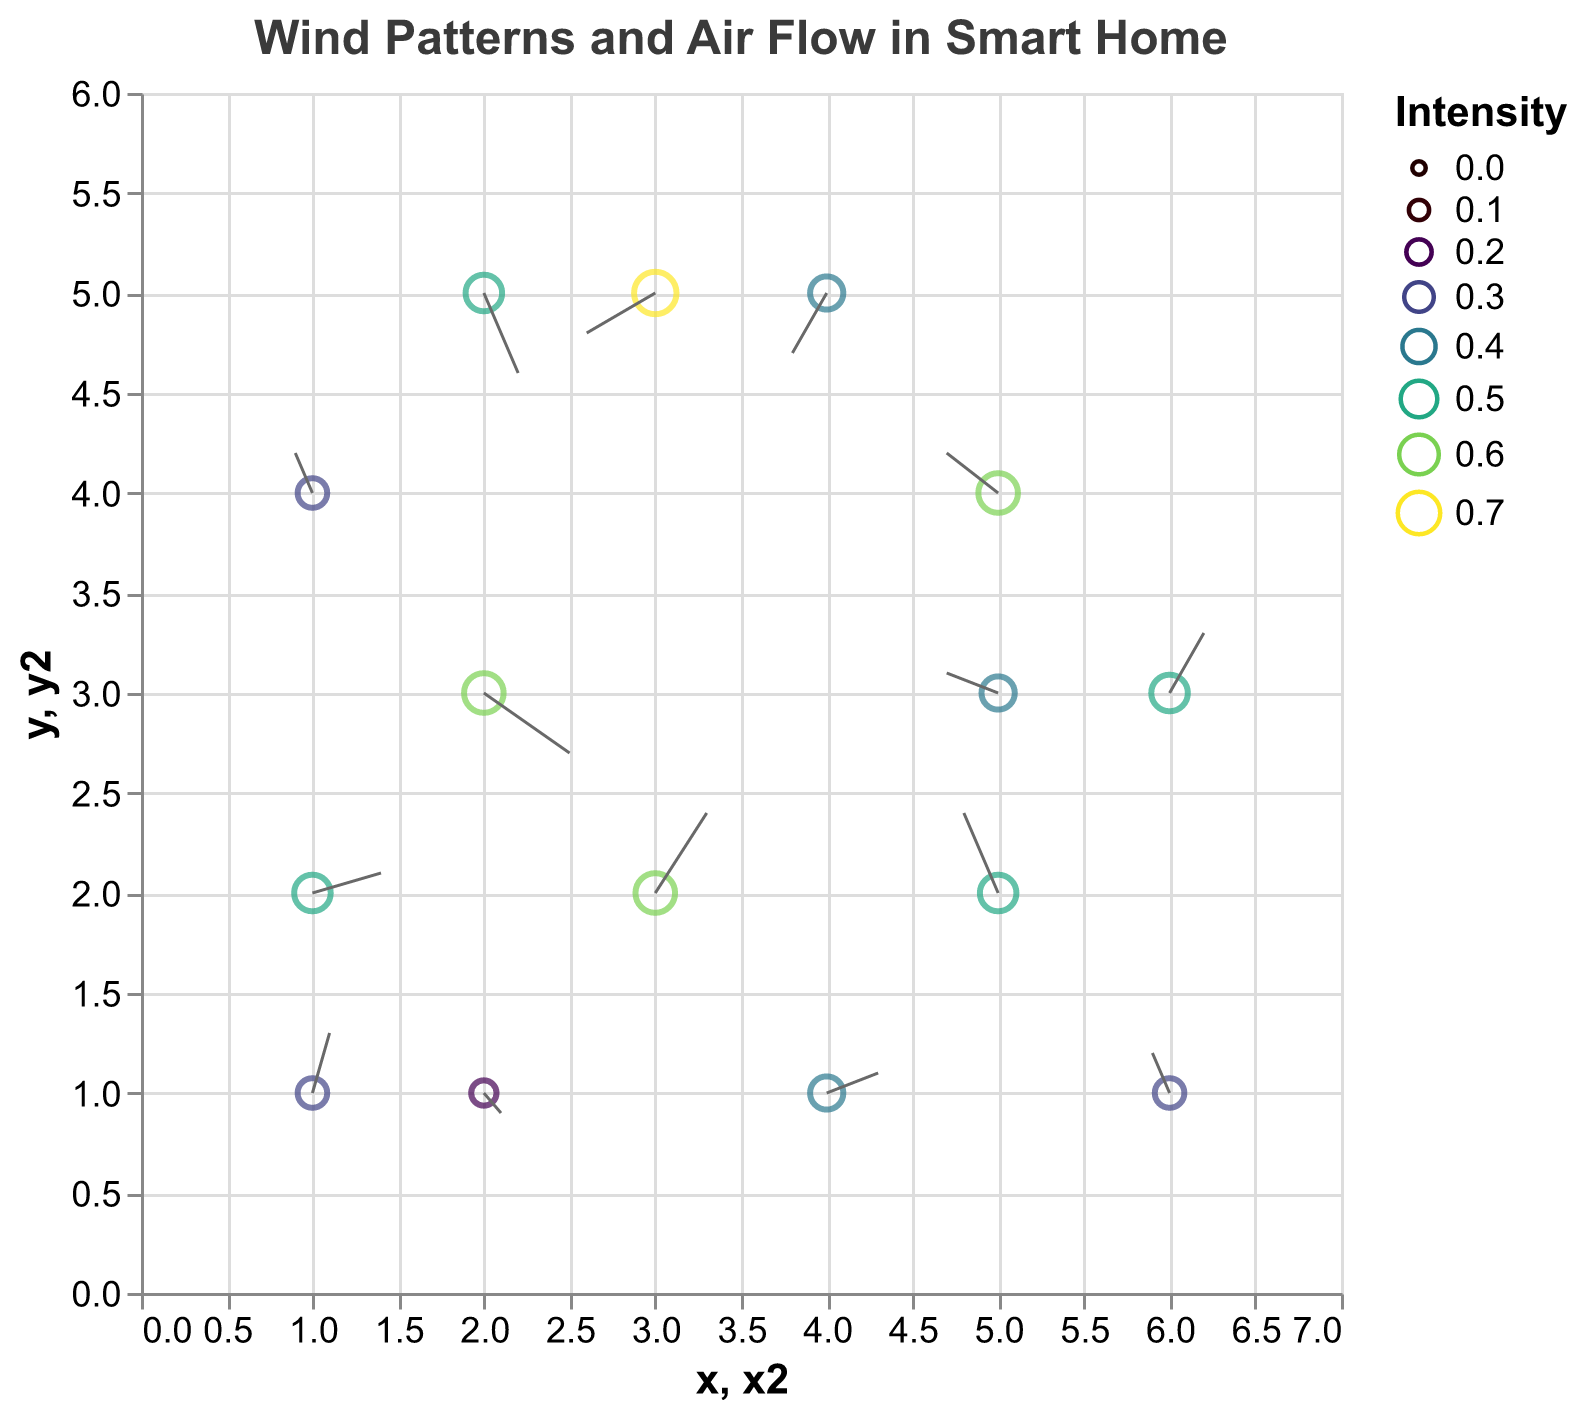How many data points are visualized in the plot? Count the number of data points based on the placement of the markers in the plot. Each marker represents a data point.
Answer: 15 What is the title of the plot? Look at the title placed at the top of the plot.
Answer: Wind Patterns and Air Flow in Smart Home Which data point has the highest air flow intensity? Identify the point with the largest marker size or the darkest color, indicating the highest intensity. This corresponds to the data point (x: 3, y: 5) with an intensity of 0.7.
Answer: (3, 5) How many data points have an air flow intensity of 0.5? Identify points with an intensity of 0.5 based on their size or color. Specifically, there are five points with an intensity of 0.5.
Answer: 5 What is the direction of air flow at (x: 2, y: 3)? Assess the direction by looking at the vector drawn from (2, 3) with a u component of 0.5 and a v component of -0.3. The vector points towards the right and slightly downward.
Answer: Right and Down Which data point has the largest upward flow? Look for the vector with the largest positive v-component. The point (5, 2) with v = 0.4 has the largest upward flow.
Answer: (5, 2) Compare the air flow intensity at (x: 1, y: 2) and (x: 5, y: 3). Which one is higher? Check the intensity at both points by evaluating their sizes or colors. The intensity at (1, 2) is 0.5, while the intensity at (5, 3) is 0.4.
Answer: (1, 2) Do any data points have both negative u and negative v components, indicating a flow to the left and downward? Look for points where both u and v components are negative. The point (3, 5) has u = -0.4 and v = -0.2, indicating a flow to the left and downward.
Answer: Yes, (3, 5) What is the average air flow intensity of all the data points? Sum all the intensity values and divide by the total number of data points (15). Sum = 6.3. Average = 6.3 / 15
Answer: 0.42 Which data point's air flow vector is closest to (x: 4, y: 1) in terms of direction? To find the closest direction, compare u and v components among other vectors. The vector at (6, 3) with u = 0.2 and v = 0.3 has similar direction components to (x: 4, y: 1) with u = 0.3 and v = 0.1.
Answer: (6, 3) 